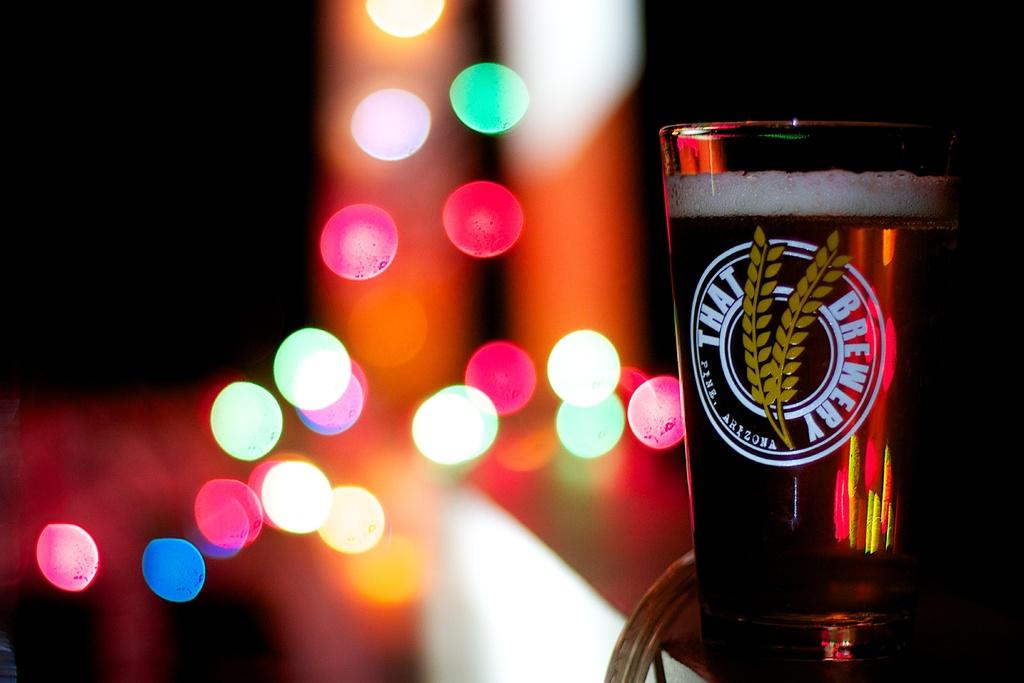<image>
Describe the image concisely. A glass of beer with the words That Brewery on it and many lights in the background. 